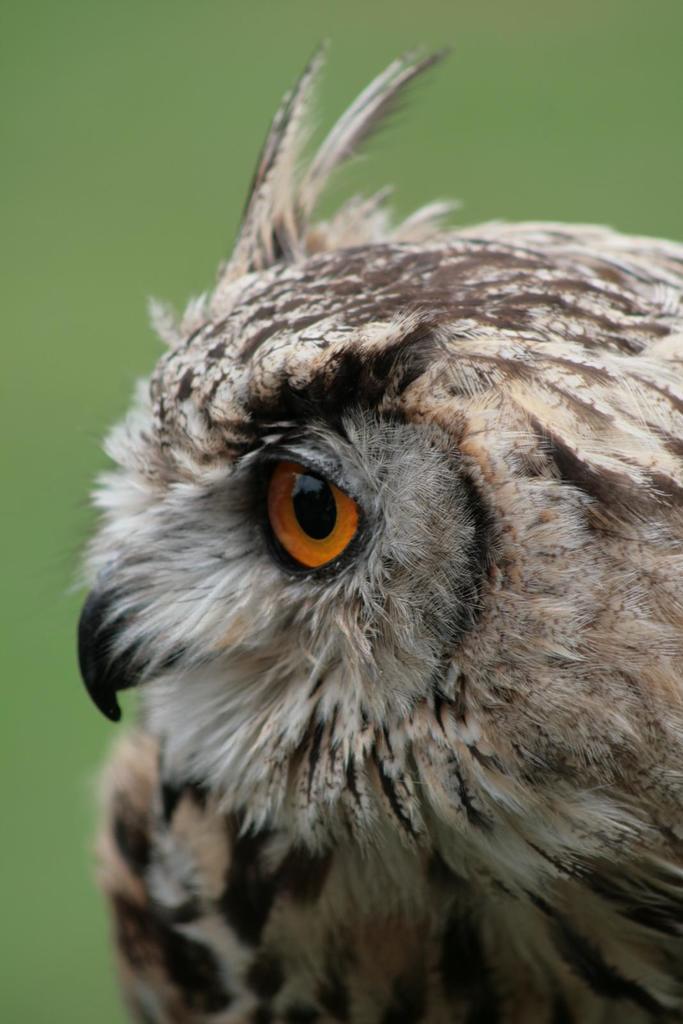Describe this image in one or two sentences. In this image we can see the bird and the background is in green color. 